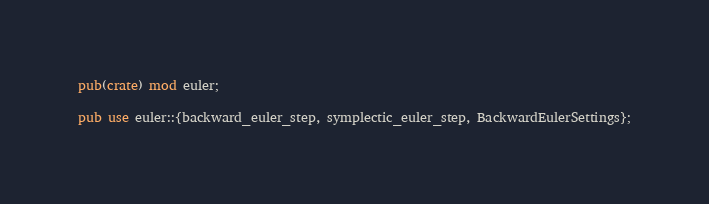Convert code to text. <code><loc_0><loc_0><loc_500><loc_500><_Rust_>pub(crate) mod euler;

pub use euler::{backward_euler_step, symplectic_euler_step, BackwardEulerSettings};
</code> 